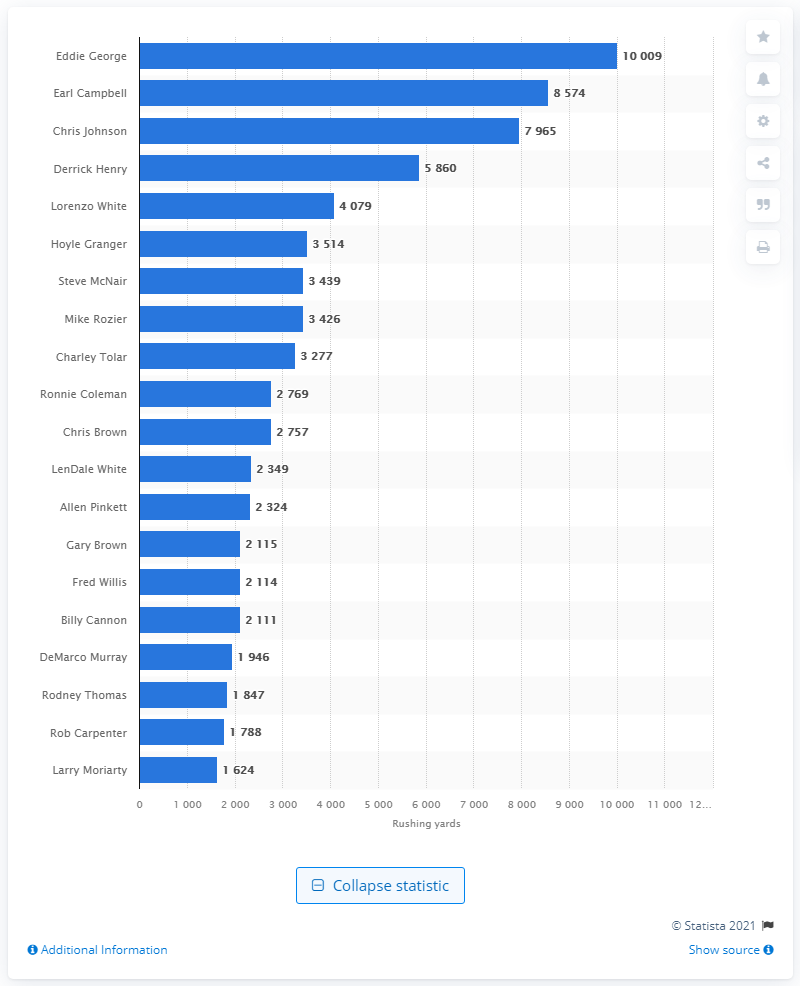Draw attention to some important aspects in this diagram. The career rushing leader of the Tennessee Titans is Eddie George. 